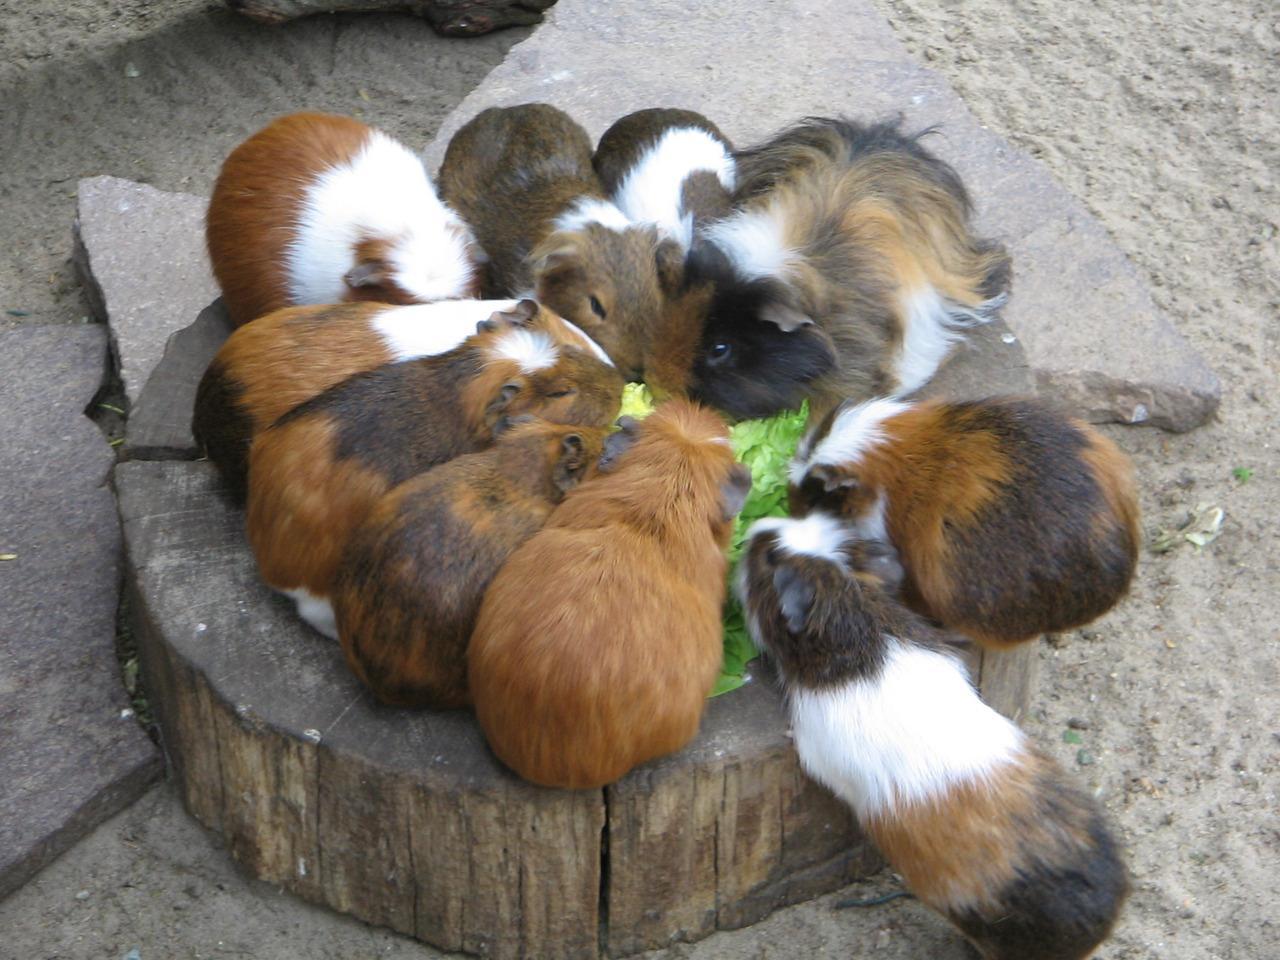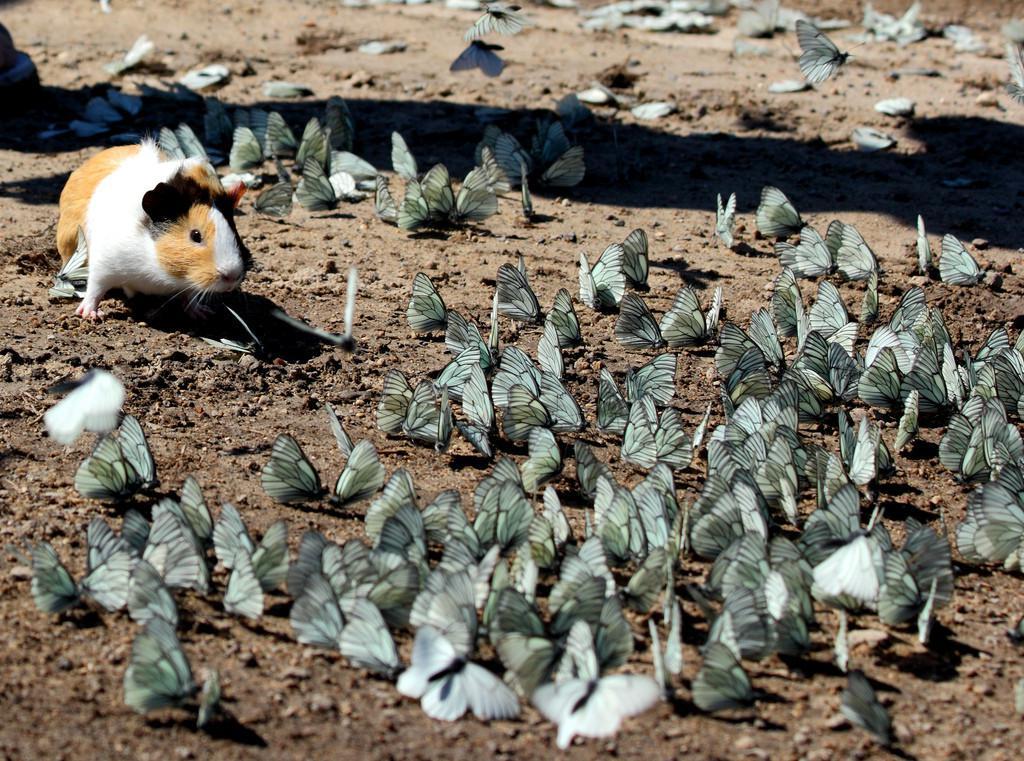The first image is the image on the left, the second image is the image on the right. Analyze the images presented: Is the assertion "Multiple hamsters surround a pile of leafy greens in at least one image." valid? Answer yes or no. Yes. The first image is the image on the left, the second image is the image on the right. Given the left and right images, does the statement "One image shows exactly one guinea pig surrounded by butterflies while the other image shows several guinea pigs." hold true? Answer yes or no. Yes. 